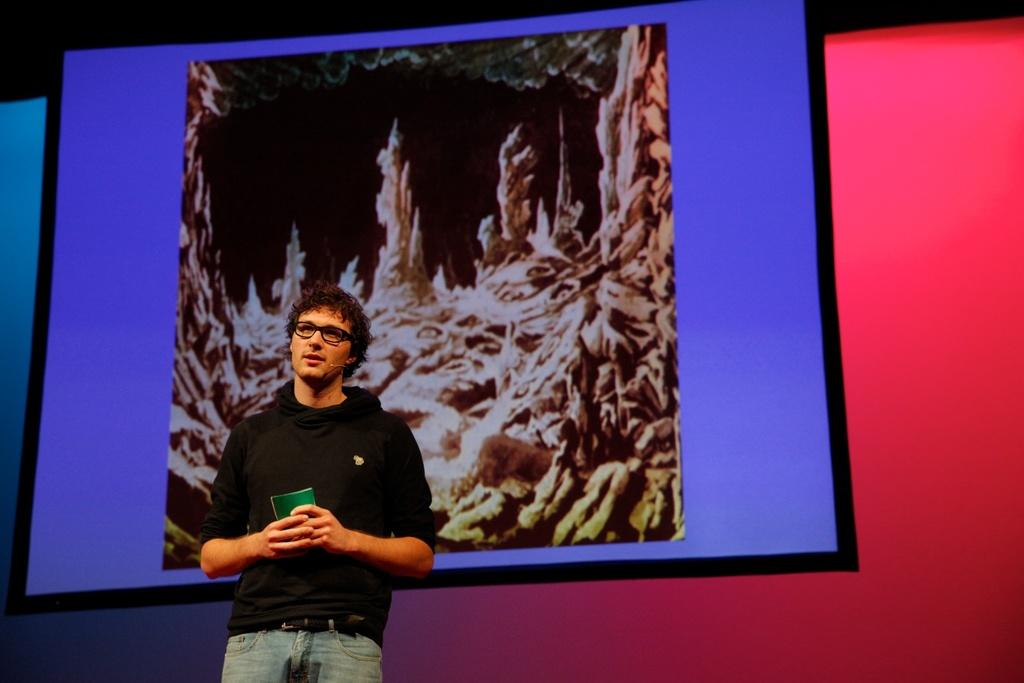What is the main subject of the image? There is a person in the image. What is the person wearing? The person is wearing a black shirt and gray pants. What can be seen in the background of the image? There is a screen in the background of the image. What colors are present on the screen? The screen has purple, pink, brown, and black colors. How does the person twist the crack in the image? There is no mention of a twist or crack in the image; it features a person wearing a black shirt and gray pants with a screen in the background. 